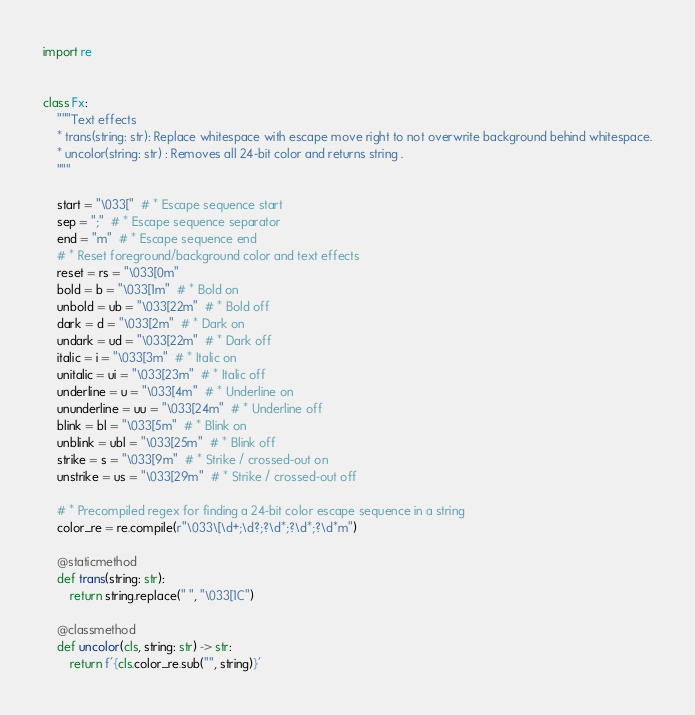Convert code to text. <code><loc_0><loc_0><loc_500><loc_500><_Python_>import re


class Fx:
    """Text effects
    * trans(string: str): Replace whitespace with escape move right to not overwrite background behind whitespace.
    * uncolor(string: str) : Removes all 24-bit color and returns string .
    """

    start = "\033["  # * Escape sequence start
    sep = ";"  # * Escape sequence separator
    end = "m"  # * Escape sequence end
    # * Reset foreground/background color and text effects
    reset = rs = "\033[0m"
    bold = b = "\033[1m"  # * Bold on
    unbold = ub = "\033[22m"  # * Bold off
    dark = d = "\033[2m"  # * Dark on
    undark = ud = "\033[22m"  # * Dark off
    italic = i = "\033[3m"  # * Italic on
    unitalic = ui = "\033[23m"  # * Italic off
    underline = u = "\033[4m"  # * Underline on
    ununderline = uu = "\033[24m"  # * Underline off
    blink = bl = "\033[5m"  # * Blink on
    unblink = ubl = "\033[25m"  # * Blink off
    strike = s = "\033[9m"  # * Strike / crossed-out on
    unstrike = us = "\033[29m"  # * Strike / crossed-out off

    # * Precompiled regex for finding a 24-bit color escape sequence in a string
    color_re = re.compile(r"\033\[\d+;\d?;?\d*;?\d*;?\d*m")

    @staticmethod
    def trans(string: str):
        return string.replace(" ", "\033[1C")

    @classmethod
    def uncolor(cls, string: str) -> str:
        return f'{cls.color_re.sub("", string)}'
</code> 